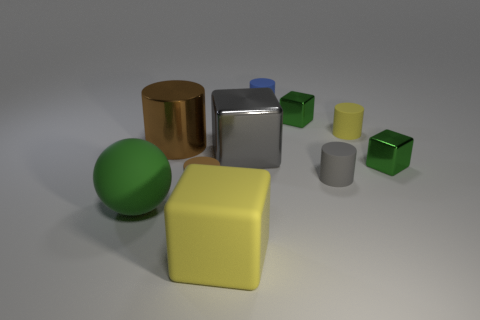Which objects in the image would be the heaviest and lightest based on size and material? Assuming the materials mimic real-world counterparts, the gold cylinder and large silver cylinder look to be the heaviest due to their size and the apparent metallic sheen indicating a denser material. On the other hand, the smallest green cube likely represents the lightest object, given its size and that it shares a similar matte appearance with the larger, presumably lightweight objects. 